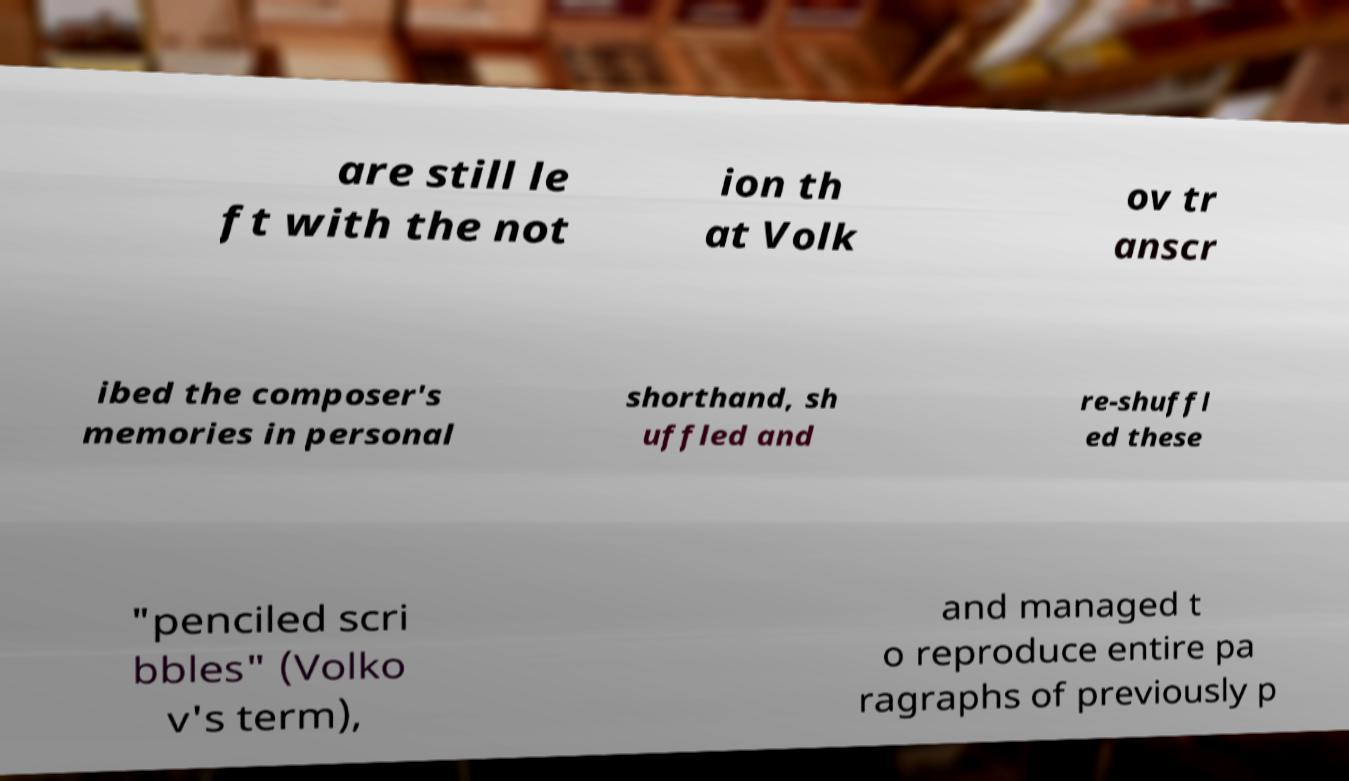Can you read and provide the text displayed in the image?This photo seems to have some interesting text. Can you extract and type it out for me? are still le ft with the not ion th at Volk ov tr anscr ibed the composer's memories in personal shorthand, sh uffled and re-shuffl ed these "penciled scri bbles" (Volko v's term), and managed t o reproduce entire pa ragraphs of previously p 